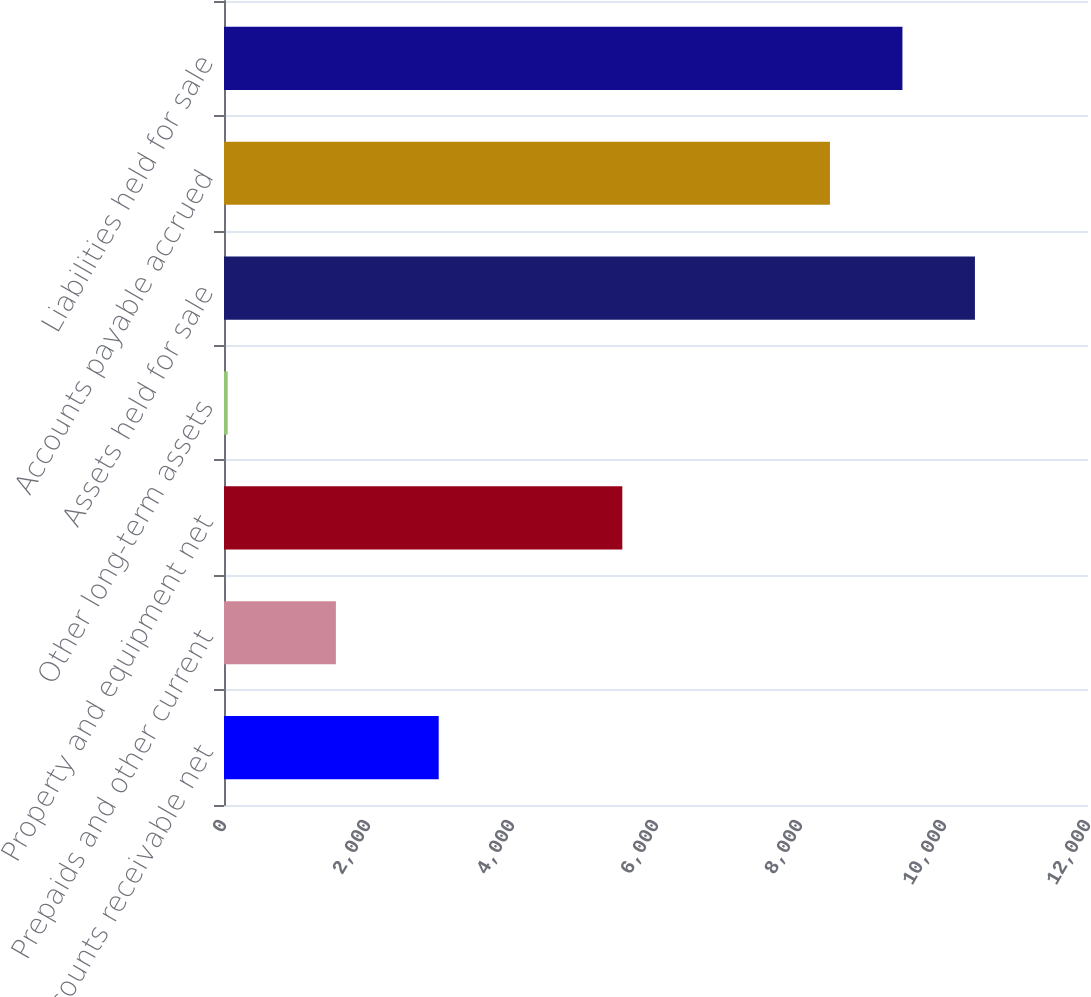Convert chart. <chart><loc_0><loc_0><loc_500><loc_500><bar_chart><fcel>Accounts receivable net<fcel>Prepaids and other current<fcel>Property and equipment net<fcel>Other long-term assets<fcel>Assets held for sale<fcel>Accounts payable accrued<fcel>Liabilities held for sale<nl><fcel>2982<fcel>1554<fcel>5532<fcel>51<fcel>10429.6<fcel>8416<fcel>9422.8<nl></chart> 